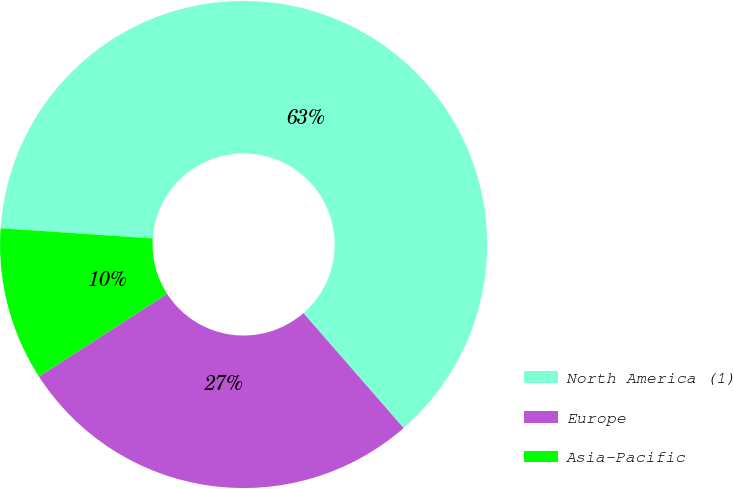Convert chart. <chart><loc_0><loc_0><loc_500><loc_500><pie_chart><fcel>North America (1)<fcel>Europe<fcel>Asia-Pacific<nl><fcel>62.53%<fcel>27.29%<fcel>10.18%<nl></chart> 